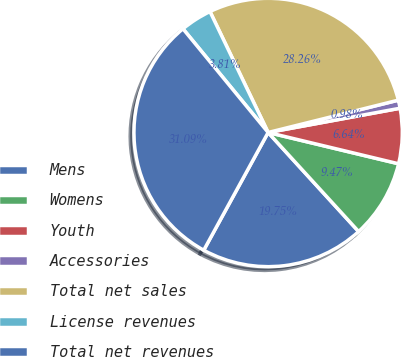Convert chart. <chart><loc_0><loc_0><loc_500><loc_500><pie_chart><fcel>Mens<fcel>Womens<fcel>Youth<fcel>Accessories<fcel>Total net sales<fcel>License revenues<fcel>Total net revenues<nl><fcel>19.75%<fcel>9.47%<fcel>6.64%<fcel>0.98%<fcel>28.26%<fcel>3.81%<fcel>31.09%<nl></chart> 